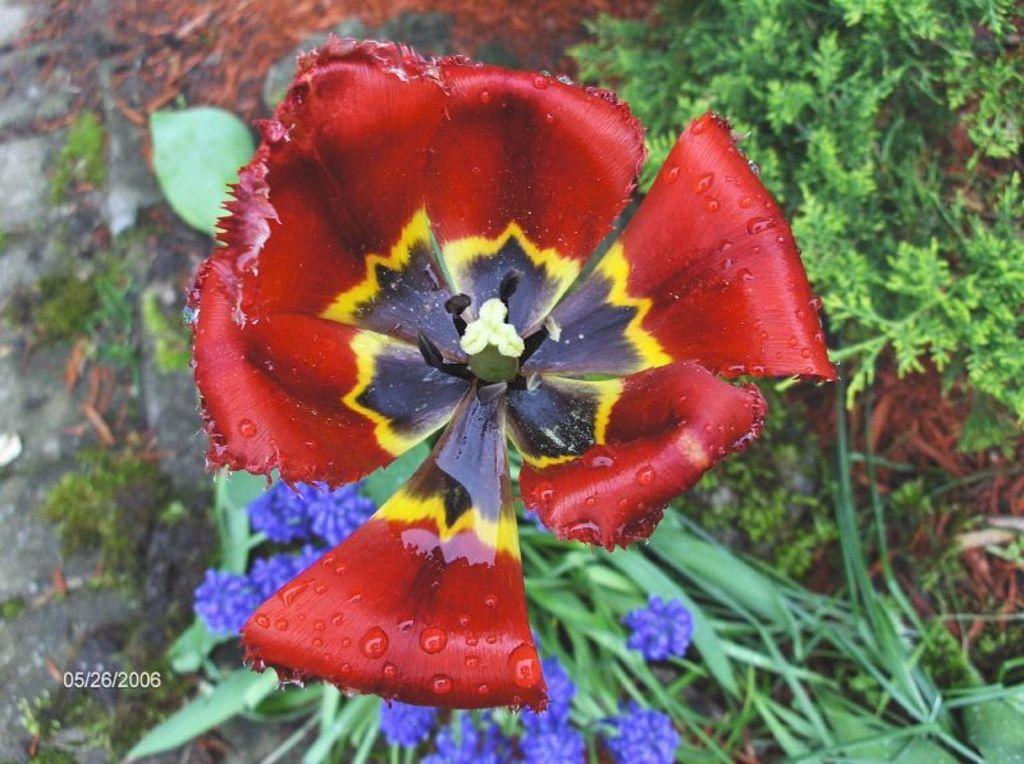Describe this image in one or two sentences. In this image I can see a red,black,yellow,white color flower. I can see few purple color flowers and green plants. 